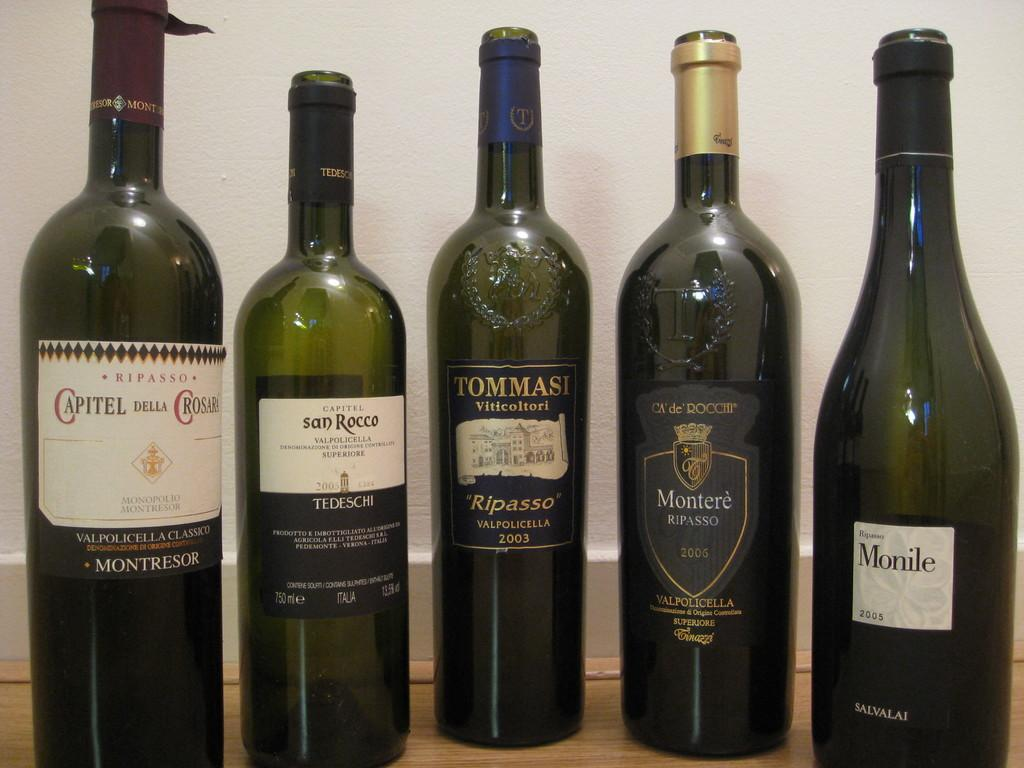<image>
Offer a succinct explanation of the picture presented. Five bottles of wine, Monile is the last bottle of the right. 